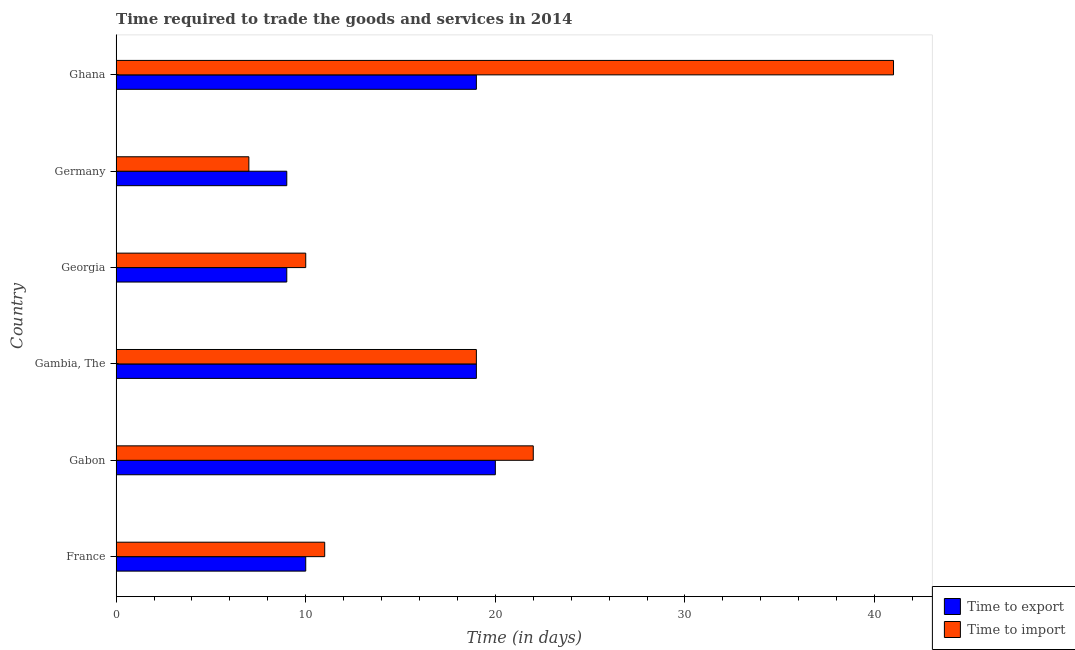How many different coloured bars are there?
Keep it short and to the point. 2. How many groups of bars are there?
Make the answer very short. 6. Are the number of bars per tick equal to the number of legend labels?
Your answer should be very brief. Yes. Are the number of bars on each tick of the Y-axis equal?
Your answer should be compact. Yes. How many bars are there on the 1st tick from the top?
Your response must be concise. 2. In how many cases, is the number of bars for a given country not equal to the number of legend labels?
Offer a terse response. 0. What is the time to export in France?
Your answer should be very brief. 10. In which country was the time to import maximum?
Provide a short and direct response. Ghana. What is the average time to import per country?
Ensure brevity in your answer.  18.33. What is the difference between the time to export and time to import in Ghana?
Provide a succinct answer. -22. What is the ratio of the time to import in France to that in Germany?
Your response must be concise. 1.57. In how many countries, is the time to export greater than the average time to export taken over all countries?
Ensure brevity in your answer.  3. Is the sum of the time to export in Gambia, The and Germany greater than the maximum time to import across all countries?
Ensure brevity in your answer.  No. What does the 1st bar from the top in Ghana represents?
Provide a short and direct response. Time to import. What does the 1st bar from the bottom in Gabon represents?
Ensure brevity in your answer.  Time to export. Are all the bars in the graph horizontal?
Your answer should be very brief. Yes. How many countries are there in the graph?
Your response must be concise. 6. What is the difference between two consecutive major ticks on the X-axis?
Provide a succinct answer. 10. Are the values on the major ticks of X-axis written in scientific E-notation?
Your response must be concise. No. Does the graph contain any zero values?
Ensure brevity in your answer.  No. Does the graph contain grids?
Give a very brief answer. No. How many legend labels are there?
Give a very brief answer. 2. What is the title of the graph?
Your answer should be compact. Time required to trade the goods and services in 2014. What is the label or title of the X-axis?
Offer a terse response. Time (in days). What is the label or title of the Y-axis?
Provide a short and direct response. Country. What is the Time (in days) in Time to import in France?
Give a very brief answer. 11. What is the Time (in days) in Time to export in Gabon?
Ensure brevity in your answer.  20. What is the Time (in days) in Time to import in Gabon?
Offer a very short reply. 22. What is the Time (in days) of Time to export in Germany?
Give a very brief answer. 9. Across all countries, what is the maximum Time (in days) in Time to export?
Provide a short and direct response. 20. Across all countries, what is the minimum Time (in days) of Time to export?
Your answer should be compact. 9. What is the total Time (in days) of Time to import in the graph?
Give a very brief answer. 110. What is the difference between the Time (in days) of Time to export in France and that in Gabon?
Make the answer very short. -10. What is the difference between the Time (in days) of Time to import in France and that in Gabon?
Offer a terse response. -11. What is the difference between the Time (in days) in Time to export in France and that in Gambia, The?
Provide a succinct answer. -9. What is the difference between the Time (in days) of Time to import in France and that in Gambia, The?
Your answer should be compact. -8. What is the difference between the Time (in days) in Time to export in France and that in Georgia?
Keep it short and to the point. 1. What is the difference between the Time (in days) of Time to import in France and that in Georgia?
Offer a very short reply. 1. What is the difference between the Time (in days) of Time to export in France and that in Germany?
Offer a very short reply. 1. What is the difference between the Time (in days) in Time to import in France and that in Germany?
Give a very brief answer. 4. What is the difference between the Time (in days) in Time to import in France and that in Ghana?
Your response must be concise. -30. What is the difference between the Time (in days) in Time to export in Gabon and that in Gambia, The?
Your answer should be compact. 1. What is the difference between the Time (in days) in Time to export in Gabon and that in Georgia?
Your answer should be very brief. 11. What is the difference between the Time (in days) in Time to export in Gabon and that in Germany?
Provide a succinct answer. 11. What is the difference between the Time (in days) of Time to import in Gabon and that in Germany?
Offer a very short reply. 15. What is the difference between the Time (in days) of Time to export in Gabon and that in Ghana?
Give a very brief answer. 1. What is the difference between the Time (in days) of Time to import in Gabon and that in Ghana?
Offer a very short reply. -19. What is the difference between the Time (in days) of Time to export in Gambia, The and that in Georgia?
Provide a short and direct response. 10. What is the difference between the Time (in days) in Time to import in Gambia, The and that in Georgia?
Make the answer very short. 9. What is the difference between the Time (in days) of Time to export in Gambia, The and that in Germany?
Provide a short and direct response. 10. What is the difference between the Time (in days) in Time to import in Gambia, The and that in Germany?
Keep it short and to the point. 12. What is the difference between the Time (in days) in Time to import in Gambia, The and that in Ghana?
Provide a succinct answer. -22. What is the difference between the Time (in days) of Time to import in Georgia and that in Ghana?
Your answer should be very brief. -31. What is the difference between the Time (in days) in Time to import in Germany and that in Ghana?
Your answer should be compact. -34. What is the difference between the Time (in days) in Time to export in France and the Time (in days) in Time to import in Georgia?
Ensure brevity in your answer.  0. What is the difference between the Time (in days) of Time to export in France and the Time (in days) of Time to import in Germany?
Your answer should be compact. 3. What is the difference between the Time (in days) in Time to export in France and the Time (in days) in Time to import in Ghana?
Offer a terse response. -31. What is the difference between the Time (in days) of Time to export in Gabon and the Time (in days) of Time to import in Georgia?
Keep it short and to the point. 10. What is the difference between the Time (in days) of Time to export in Gabon and the Time (in days) of Time to import in Germany?
Ensure brevity in your answer.  13. What is the difference between the Time (in days) of Time to export in Gabon and the Time (in days) of Time to import in Ghana?
Offer a very short reply. -21. What is the difference between the Time (in days) of Time to export in Gambia, The and the Time (in days) of Time to import in Germany?
Ensure brevity in your answer.  12. What is the difference between the Time (in days) in Time to export in Gambia, The and the Time (in days) in Time to import in Ghana?
Give a very brief answer. -22. What is the difference between the Time (in days) in Time to export in Georgia and the Time (in days) in Time to import in Ghana?
Ensure brevity in your answer.  -32. What is the difference between the Time (in days) in Time to export in Germany and the Time (in days) in Time to import in Ghana?
Your response must be concise. -32. What is the average Time (in days) in Time to export per country?
Offer a very short reply. 14.33. What is the average Time (in days) in Time to import per country?
Your answer should be compact. 18.33. What is the difference between the Time (in days) of Time to export and Time (in days) of Time to import in France?
Provide a succinct answer. -1. What is the difference between the Time (in days) in Time to export and Time (in days) in Time to import in Gabon?
Provide a short and direct response. -2. What is the difference between the Time (in days) of Time to export and Time (in days) of Time to import in Gambia, The?
Provide a succinct answer. 0. What is the difference between the Time (in days) of Time to export and Time (in days) of Time to import in Germany?
Ensure brevity in your answer.  2. What is the difference between the Time (in days) in Time to export and Time (in days) in Time to import in Ghana?
Provide a succinct answer. -22. What is the ratio of the Time (in days) in Time to export in France to that in Gabon?
Provide a succinct answer. 0.5. What is the ratio of the Time (in days) of Time to import in France to that in Gabon?
Your answer should be very brief. 0.5. What is the ratio of the Time (in days) in Time to export in France to that in Gambia, The?
Provide a succinct answer. 0.53. What is the ratio of the Time (in days) in Time to import in France to that in Gambia, The?
Offer a very short reply. 0.58. What is the ratio of the Time (in days) of Time to export in France to that in Georgia?
Your response must be concise. 1.11. What is the ratio of the Time (in days) in Time to import in France to that in Georgia?
Your answer should be compact. 1.1. What is the ratio of the Time (in days) of Time to export in France to that in Germany?
Your answer should be very brief. 1.11. What is the ratio of the Time (in days) of Time to import in France to that in Germany?
Your response must be concise. 1.57. What is the ratio of the Time (in days) of Time to export in France to that in Ghana?
Provide a short and direct response. 0.53. What is the ratio of the Time (in days) of Time to import in France to that in Ghana?
Your answer should be very brief. 0.27. What is the ratio of the Time (in days) in Time to export in Gabon to that in Gambia, The?
Provide a short and direct response. 1.05. What is the ratio of the Time (in days) in Time to import in Gabon to that in Gambia, The?
Your response must be concise. 1.16. What is the ratio of the Time (in days) in Time to export in Gabon to that in Georgia?
Give a very brief answer. 2.22. What is the ratio of the Time (in days) of Time to import in Gabon to that in Georgia?
Your response must be concise. 2.2. What is the ratio of the Time (in days) of Time to export in Gabon to that in Germany?
Provide a succinct answer. 2.22. What is the ratio of the Time (in days) in Time to import in Gabon to that in Germany?
Your answer should be very brief. 3.14. What is the ratio of the Time (in days) in Time to export in Gabon to that in Ghana?
Make the answer very short. 1.05. What is the ratio of the Time (in days) in Time to import in Gabon to that in Ghana?
Make the answer very short. 0.54. What is the ratio of the Time (in days) in Time to export in Gambia, The to that in Georgia?
Offer a terse response. 2.11. What is the ratio of the Time (in days) in Time to export in Gambia, The to that in Germany?
Your answer should be very brief. 2.11. What is the ratio of the Time (in days) of Time to import in Gambia, The to that in Germany?
Your answer should be very brief. 2.71. What is the ratio of the Time (in days) of Time to import in Gambia, The to that in Ghana?
Your answer should be compact. 0.46. What is the ratio of the Time (in days) of Time to import in Georgia to that in Germany?
Your response must be concise. 1.43. What is the ratio of the Time (in days) of Time to export in Georgia to that in Ghana?
Offer a very short reply. 0.47. What is the ratio of the Time (in days) in Time to import in Georgia to that in Ghana?
Provide a succinct answer. 0.24. What is the ratio of the Time (in days) in Time to export in Germany to that in Ghana?
Ensure brevity in your answer.  0.47. What is the ratio of the Time (in days) in Time to import in Germany to that in Ghana?
Your answer should be very brief. 0.17. What is the difference between the highest and the lowest Time (in days) of Time to export?
Keep it short and to the point. 11. What is the difference between the highest and the lowest Time (in days) in Time to import?
Provide a short and direct response. 34. 